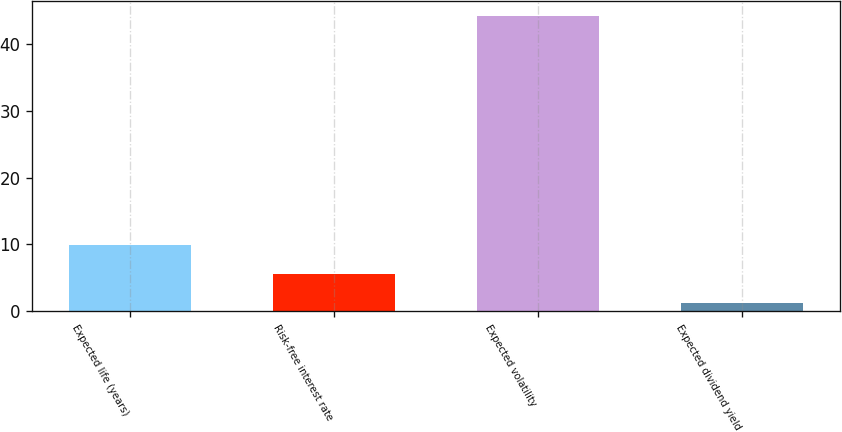Convert chart to OTSL. <chart><loc_0><loc_0><loc_500><loc_500><bar_chart><fcel>Expected life (years)<fcel>Risk-free interest rate<fcel>Expected volatility<fcel>Expected dividend yield<nl><fcel>9.9<fcel>5.51<fcel>44.3<fcel>1.2<nl></chart> 